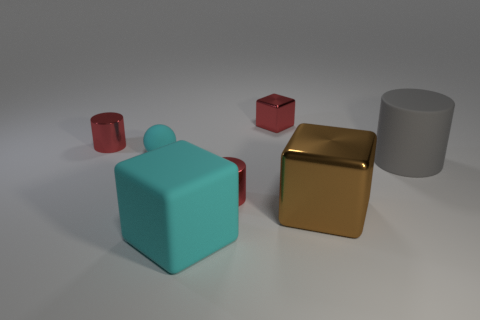Add 3 red shiny blocks. How many objects exist? 10 Subtract all red cubes. How many cubes are left? 2 Subtract all red metal cubes. How many cubes are left? 2 Subtract 0 purple cylinders. How many objects are left? 7 Subtract all cubes. How many objects are left? 4 Subtract 3 blocks. How many blocks are left? 0 Subtract all purple cylinders. Subtract all purple spheres. How many cylinders are left? 3 Subtract all purple cubes. How many gray cylinders are left? 1 Subtract all small balls. Subtract all large gray cylinders. How many objects are left? 5 Add 5 tiny cyan balls. How many tiny cyan balls are left? 6 